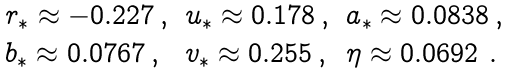Convert formula to latex. <formula><loc_0><loc_0><loc_500><loc_500>\begin{array} { l l l } r _ { \ast } \approx - 0 . 2 2 7 \, , & u _ { \ast } \approx 0 . 1 7 8 \, , & a _ { \ast } \approx 0 . 0 8 3 8 \, , \\ b _ { \ast } \approx 0 . 0 7 6 7 \, , & v _ { \ast } \approx 0 . 2 5 5 \, , & \eta \approx 0 . 0 6 9 2 \ . \end{array}</formula> 